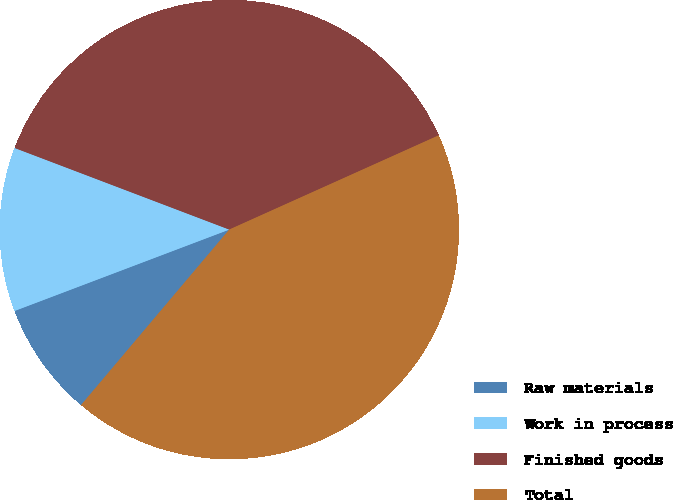<chart> <loc_0><loc_0><loc_500><loc_500><pie_chart><fcel>Raw materials<fcel>Work in process<fcel>Finished goods<fcel>Total<nl><fcel>8.07%<fcel>11.55%<fcel>37.49%<fcel>42.89%<nl></chart> 